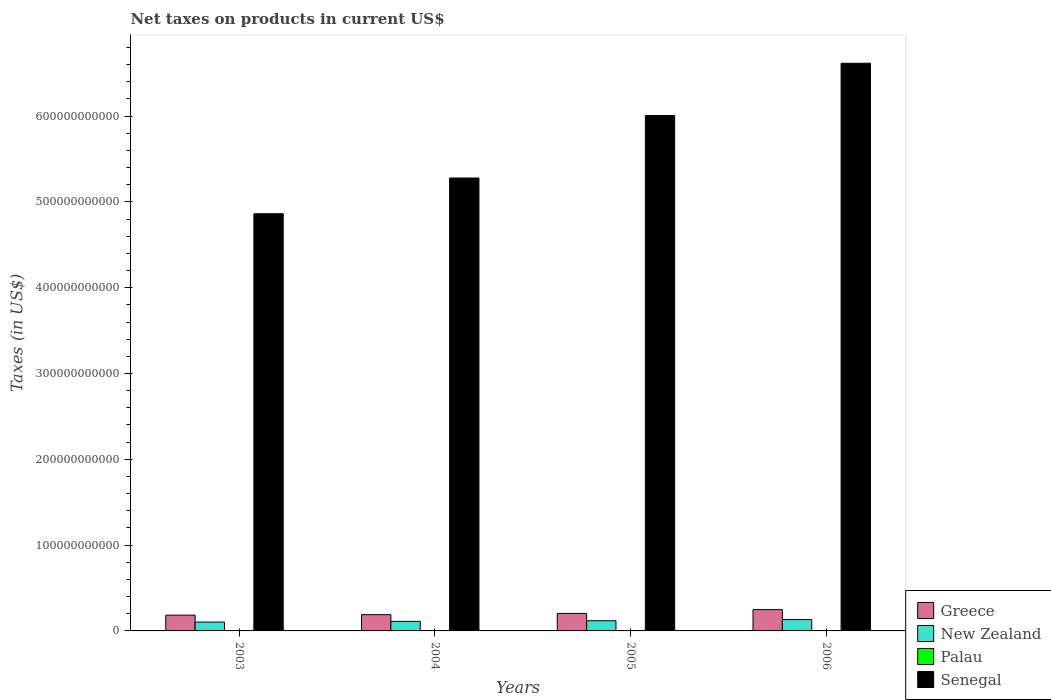How many different coloured bars are there?
Your answer should be compact. 4. What is the label of the 3rd group of bars from the left?
Offer a terse response. 2005. In how many cases, is the number of bars for a given year not equal to the number of legend labels?
Keep it short and to the point. 0. What is the net taxes on products in Greece in 2005?
Make the answer very short. 2.04e+1. Across all years, what is the maximum net taxes on products in Greece?
Your response must be concise. 2.48e+1. Across all years, what is the minimum net taxes on products in Greece?
Offer a very short reply. 1.84e+1. In which year was the net taxes on products in Greece maximum?
Make the answer very short. 2006. What is the total net taxes on products in Palau in the graph?
Provide a succinct answer. 6.83e+07. What is the difference between the net taxes on products in Senegal in 2004 and that in 2005?
Provide a succinct answer. -7.28e+1. What is the difference between the net taxes on products in New Zealand in 2006 and the net taxes on products in Senegal in 2004?
Make the answer very short. -5.15e+11. What is the average net taxes on products in Greece per year?
Provide a succinct answer. 2.06e+1. In the year 2005, what is the difference between the net taxes on products in New Zealand and net taxes on products in Palau?
Offer a terse response. 1.18e+1. In how many years, is the net taxes on products in Senegal greater than 280000000000 US$?
Offer a very short reply. 4. What is the ratio of the net taxes on products in Senegal in 2005 to that in 2006?
Make the answer very short. 0.91. Is the net taxes on products in New Zealand in 2005 less than that in 2006?
Offer a terse response. Yes. Is the difference between the net taxes on products in New Zealand in 2005 and 2006 greater than the difference between the net taxes on products in Palau in 2005 and 2006?
Provide a short and direct response. No. What is the difference between the highest and the second highest net taxes on products in Senegal?
Provide a short and direct response. 6.09e+1. What is the difference between the highest and the lowest net taxes on products in Senegal?
Offer a very short reply. 1.75e+11. Is the sum of the net taxes on products in New Zealand in 2003 and 2006 greater than the maximum net taxes on products in Senegal across all years?
Offer a terse response. No. What does the 2nd bar from the left in 2006 represents?
Offer a terse response. New Zealand. What does the 1st bar from the right in 2003 represents?
Keep it short and to the point. Senegal. Is it the case that in every year, the sum of the net taxes on products in Greece and net taxes on products in Senegal is greater than the net taxes on products in Palau?
Your answer should be very brief. Yes. How many years are there in the graph?
Provide a succinct answer. 4. What is the difference between two consecutive major ticks on the Y-axis?
Give a very brief answer. 1.00e+11. Are the values on the major ticks of Y-axis written in scientific E-notation?
Keep it short and to the point. No. Does the graph contain grids?
Your response must be concise. No. Where does the legend appear in the graph?
Offer a terse response. Bottom right. How many legend labels are there?
Your answer should be very brief. 4. What is the title of the graph?
Offer a very short reply. Net taxes on products in current US$. Does "Brazil" appear as one of the legend labels in the graph?
Your response must be concise. No. What is the label or title of the Y-axis?
Offer a terse response. Taxes (in US$). What is the Taxes (in US$) of Greece in 2003?
Your answer should be very brief. 1.84e+1. What is the Taxes (in US$) of New Zealand in 2003?
Provide a short and direct response. 1.03e+1. What is the Taxes (in US$) in Palau in 2003?
Provide a succinct answer. 1.38e+07. What is the Taxes (in US$) in Senegal in 2003?
Give a very brief answer. 4.86e+11. What is the Taxes (in US$) in Greece in 2004?
Keep it short and to the point. 1.89e+1. What is the Taxes (in US$) in New Zealand in 2004?
Offer a very short reply. 1.11e+1. What is the Taxes (in US$) in Palau in 2004?
Offer a very short reply. 1.66e+07. What is the Taxes (in US$) of Senegal in 2004?
Offer a very short reply. 5.28e+11. What is the Taxes (in US$) of Greece in 2005?
Provide a succinct answer. 2.04e+1. What is the Taxes (in US$) of New Zealand in 2005?
Give a very brief answer. 1.18e+1. What is the Taxes (in US$) of Palau in 2005?
Your answer should be very brief. 1.94e+07. What is the Taxes (in US$) in Senegal in 2005?
Your answer should be compact. 6.01e+11. What is the Taxes (in US$) in Greece in 2006?
Provide a succinct answer. 2.48e+1. What is the Taxes (in US$) of New Zealand in 2006?
Make the answer very short. 1.33e+1. What is the Taxes (in US$) of Palau in 2006?
Provide a short and direct response. 1.84e+07. What is the Taxes (in US$) of Senegal in 2006?
Provide a short and direct response. 6.62e+11. Across all years, what is the maximum Taxes (in US$) of Greece?
Provide a short and direct response. 2.48e+1. Across all years, what is the maximum Taxes (in US$) in New Zealand?
Offer a very short reply. 1.33e+1. Across all years, what is the maximum Taxes (in US$) in Palau?
Ensure brevity in your answer.  1.94e+07. Across all years, what is the maximum Taxes (in US$) of Senegal?
Your answer should be very brief. 6.62e+11. Across all years, what is the minimum Taxes (in US$) of Greece?
Give a very brief answer. 1.84e+1. Across all years, what is the minimum Taxes (in US$) in New Zealand?
Offer a very short reply. 1.03e+1. Across all years, what is the minimum Taxes (in US$) of Palau?
Provide a short and direct response. 1.38e+07. Across all years, what is the minimum Taxes (in US$) of Senegal?
Give a very brief answer. 4.86e+11. What is the total Taxes (in US$) in Greece in the graph?
Offer a very short reply. 8.26e+1. What is the total Taxes (in US$) in New Zealand in the graph?
Ensure brevity in your answer.  4.65e+1. What is the total Taxes (in US$) in Palau in the graph?
Your answer should be compact. 6.83e+07. What is the total Taxes (in US$) in Senegal in the graph?
Your answer should be compact. 2.28e+12. What is the difference between the Taxes (in US$) of Greece in 2003 and that in 2004?
Your answer should be compact. -5.51e+08. What is the difference between the Taxes (in US$) in New Zealand in 2003 and that in 2004?
Your answer should be very brief. -8.52e+08. What is the difference between the Taxes (in US$) in Palau in 2003 and that in 2004?
Your response must be concise. -2.81e+06. What is the difference between the Taxes (in US$) in Senegal in 2003 and that in 2004?
Give a very brief answer. -4.17e+1. What is the difference between the Taxes (in US$) of Greece in 2003 and that in 2005?
Your answer should be compact. -2.03e+09. What is the difference between the Taxes (in US$) in New Zealand in 2003 and that in 2005?
Offer a very short reply. -1.55e+09. What is the difference between the Taxes (in US$) of Palau in 2003 and that in 2005?
Offer a very short reply. -5.60e+06. What is the difference between the Taxes (in US$) in Senegal in 2003 and that in 2005?
Give a very brief answer. -1.14e+11. What is the difference between the Taxes (in US$) in Greece in 2003 and that in 2006?
Keep it short and to the point. -6.42e+09. What is the difference between the Taxes (in US$) in New Zealand in 2003 and that in 2006?
Your response must be concise. -2.96e+09. What is the difference between the Taxes (in US$) in Palau in 2003 and that in 2006?
Your answer should be compact. -4.54e+06. What is the difference between the Taxes (in US$) in Senegal in 2003 and that in 2006?
Keep it short and to the point. -1.75e+11. What is the difference between the Taxes (in US$) in Greece in 2004 and that in 2005?
Your response must be concise. -1.48e+09. What is the difference between the Taxes (in US$) of New Zealand in 2004 and that in 2005?
Offer a terse response. -6.97e+08. What is the difference between the Taxes (in US$) of Palau in 2004 and that in 2005?
Ensure brevity in your answer.  -2.78e+06. What is the difference between the Taxes (in US$) in Senegal in 2004 and that in 2005?
Your answer should be compact. -7.28e+1. What is the difference between the Taxes (in US$) in Greece in 2004 and that in 2006?
Make the answer very short. -5.87e+09. What is the difference between the Taxes (in US$) of New Zealand in 2004 and that in 2006?
Make the answer very short. -2.11e+09. What is the difference between the Taxes (in US$) in Palau in 2004 and that in 2006?
Ensure brevity in your answer.  -1.73e+06. What is the difference between the Taxes (in US$) of Senegal in 2004 and that in 2006?
Your answer should be compact. -1.34e+11. What is the difference between the Taxes (in US$) of Greece in 2005 and that in 2006?
Your answer should be very brief. -4.39e+09. What is the difference between the Taxes (in US$) in New Zealand in 2005 and that in 2006?
Make the answer very short. -1.41e+09. What is the difference between the Taxes (in US$) in Palau in 2005 and that in 2006?
Offer a terse response. 1.05e+06. What is the difference between the Taxes (in US$) of Senegal in 2005 and that in 2006?
Make the answer very short. -6.09e+1. What is the difference between the Taxes (in US$) of Greece in 2003 and the Taxes (in US$) of New Zealand in 2004?
Provide a succinct answer. 7.25e+09. What is the difference between the Taxes (in US$) in Greece in 2003 and the Taxes (in US$) in Palau in 2004?
Your answer should be compact. 1.84e+1. What is the difference between the Taxes (in US$) of Greece in 2003 and the Taxes (in US$) of Senegal in 2004?
Offer a very short reply. -5.09e+11. What is the difference between the Taxes (in US$) in New Zealand in 2003 and the Taxes (in US$) in Palau in 2004?
Make the answer very short. 1.03e+1. What is the difference between the Taxes (in US$) of New Zealand in 2003 and the Taxes (in US$) of Senegal in 2004?
Keep it short and to the point. -5.18e+11. What is the difference between the Taxes (in US$) of Palau in 2003 and the Taxes (in US$) of Senegal in 2004?
Keep it short and to the point. -5.28e+11. What is the difference between the Taxes (in US$) in Greece in 2003 and the Taxes (in US$) in New Zealand in 2005?
Make the answer very short. 6.55e+09. What is the difference between the Taxes (in US$) of Greece in 2003 and the Taxes (in US$) of Palau in 2005?
Ensure brevity in your answer.  1.84e+1. What is the difference between the Taxes (in US$) in Greece in 2003 and the Taxes (in US$) in Senegal in 2005?
Offer a very short reply. -5.82e+11. What is the difference between the Taxes (in US$) in New Zealand in 2003 and the Taxes (in US$) in Palau in 2005?
Give a very brief answer. 1.03e+1. What is the difference between the Taxes (in US$) in New Zealand in 2003 and the Taxes (in US$) in Senegal in 2005?
Give a very brief answer. -5.90e+11. What is the difference between the Taxes (in US$) in Palau in 2003 and the Taxes (in US$) in Senegal in 2005?
Your answer should be very brief. -6.01e+11. What is the difference between the Taxes (in US$) in Greece in 2003 and the Taxes (in US$) in New Zealand in 2006?
Offer a very short reply. 5.14e+09. What is the difference between the Taxes (in US$) in Greece in 2003 and the Taxes (in US$) in Palau in 2006?
Provide a short and direct response. 1.84e+1. What is the difference between the Taxes (in US$) in Greece in 2003 and the Taxes (in US$) in Senegal in 2006?
Provide a succinct answer. -6.43e+11. What is the difference between the Taxes (in US$) of New Zealand in 2003 and the Taxes (in US$) of Palau in 2006?
Ensure brevity in your answer.  1.03e+1. What is the difference between the Taxes (in US$) in New Zealand in 2003 and the Taxes (in US$) in Senegal in 2006?
Ensure brevity in your answer.  -6.51e+11. What is the difference between the Taxes (in US$) of Palau in 2003 and the Taxes (in US$) of Senegal in 2006?
Keep it short and to the point. -6.62e+11. What is the difference between the Taxes (in US$) of Greece in 2004 and the Taxes (in US$) of New Zealand in 2005?
Offer a very short reply. 7.10e+09. What is the difference between the Taxes (in US$) in Greece in 2004 and the Taxes (in US$) in Palau in 2005?
Offer a very short reply. 1.89e+1. What is the difference between the Taxes (in US$) of Greece in 2004 and the Taxes (in US$) of Senegal in 2005?
Provide a short and direct response. -5.82e+11. What is the difference between the Taxes (in US$) of New Zealand in 2004 and the Taxes (in US$) of Palau in 2005?
Your answer should be compact. 1.11e+1. What is the difference between the Taxes (in US$) of New Zealand in 2004 and the Taxes (in US$) of Senegal in 2005?
Your answer should be compact. -5.90e+11. What is the difference between the Taxes (in US$) in Palau in 2004 and the Taxes (in US$) in Senegal in 2005?
Keep it short and to the point. -6.01e+11. What is the difference between the Taxes (in US$) in Greece in 2004 and the Taxes (in US$) in New Zealand in 2006?
Give a very brief answer. 5.69e+09. What is the difference between the Taxes (in US$) of Greece in 2004 and the Taxes (in US$) of Palau in 2006?
Your response must be concise. 1.89e+1. What is the difference between the Taxes (in US$) of Greece in 2004 and the Taxes (in US$) of Senegal in 2006?
Provide a short and direct response. -6.43e+11. What is the difference between the Taxes (in US$) in New Zealand in 2004 and the Taxes (in US$) in Palau in 2006?
Give a very brief answer. 1.11e+1. What is the difference between the Taxes (in US$) in New Zealand in 2004 and the Taxes (in US$) in Senegal in 2006?
Your answer should be very brief. -6.50e+11. What is the difference between the Taxes (in US$) in Palau in 2004 and the Taxes (in US$) in Senegal in 2006?
Your answer should be very brief. -6.62e+11. What is the difference between the Taxes (in US$) in Greece in 2005 and the Taxes (in US$) in New Zealand in 2006?
Provide a succinct answer. 7.17e+09. What is the difference between the Taxes (in US$) of Greece in 2005 and the Taxes (in US$) of Palau in 2006?
Offer a terse response. 2.04e+1. What is the difference between the Taxes (in US$) in Greece in 2005 and the Taxes (in US$) in Senegal in 2006?
Your answer should be compact. -6.41e+11. What is the difference between the Taxes (in US$) of New Zealand in 2005 and the Taxes (in US$) of Palau in 2006?
Keep it short and to the point. 1.18e+1. What is the difference between the Taxes (in US$) of New Zealand in 2005 and the Taxes (in US$) of Senegal in 2006?
Make the answer very short. -6.50e+11. What is the difference between the Taxes (in US$) of Palau in 2005 and the Taxes (in US$) of Senegal in 2006?
Offer a very short reply. -6.62e+11. What is the average Taxes (in US$) in Greece per year?
Your answer should be compact. 2.06e+1. What is the average Taxes (in US$) in New Zealand per year?
Make the answer very short. 1.16e+1. What is the average Taxes (in US$) of Palau per year?
Provide a short and direct response. 1.71e+07. What is the average Taxes (in US$) in Senegal per year?
Provide a succinct answer. 5.69e+11. In the year 2003, what is the difference between the Taxes (in US$) in Greece and Taxes (in US$) in New Zealand?
Provide a succinct answer. 8.10e+09. In the year 2003, what is the difference between the Taxes (in US$) in Greece and Taxes (in US$) in Palau?
Your answer should be very brief. 1.84e+1. In the year 2003, what is the difference between the Taxes (in US$) in Greece and Taxes (in US$) in Senegal?
Your answer should be very brief. -4.68e+11. In the year 2003, what is the difference between the Taxes (in US$) of New Zealand and Taxes (in US$) of Palau?
Provide a short and direct response. 1.03e+1. In the year 2003, what is the difference between the Taxes (in US$) in New Zealand and Taxes (in US$) in Senegal?
Make the answer very short. -4.76e+11. In the year 2003, what is the difference between the Taxes (in US$) in Palau and Taxes (in US$) in Senegal?
Make the answer very short. -4.86e+11. In the year 2004, what is the difference between the Taxes (in US$) of Greece and Taxes (in US$) of New Zealand?
Your answer should be very brief. 7.80e+09. In the year 2004, what is the difference between the Taxes (in US$) of Greece and Taxes (in US$) of Palau?
Offer a very short reply. 1.89e+1. In the year 2004, what is the difference between the Taxes (in US$) of Greece and Taxes (in US$) of Senegal?
Your answer should be compact. -5.09e+11. In the year 2004, what is the difference between the Taxes (in US$) in New Zealand and Taxes (in US$) in Palau?
Give a very brief answer. 1.11e+1. In the year 2004, what is the difference between the Taxes (in US$) of New Zealand and Taxes (in US$) of Senegal?
Give a very brief answer. -5.17e+11. In the year 2004, what is the difference between the Taxes (in US$) in Palau and Taxes (in US$) in Senegal?
Offer a terse response. -5.28e+11. In the year 2005, what is the difference between the Taxes (in US$) of Greece and Taxes (in US$) of New Zealand?
Your response must be concise. 8.58e+09. In the year 2005, what is the difference between the Taxes (in US$) in Greece and Taxes (in US$) in Palau?
Your response must be concise. 2.04e+1. In the year 2005, what is the difference between the Taxes (in US$) of Greece and Taxes (in US$) of Senegal?
Your answer should be very brief. -5.80e+11. In the year 2005, what is the difference between the Taxes (in US$) in New Zealand and Taxes (in US$) in Palau?
Keep it short and to the point. 1.18e+1. In the year 2005, what is the difference between the Taxes (in US$) in New Zealand and Taxes (in US$) in Senegal?
Keep it short and to the point. -5.89e+11. In the year 2005, what is the difference between the Taxes (in US$) in Palau and Taxes (in US$) in Senegal?
Make the answer very short. -6.01e+11. In the year 2006, what is the difference between the Taxes (in US$) of Greece and Taxes (in US$) of New Zealand?
Your answer should be very brief. 1.16e+1. In the year 2006, what is the difference between the Taxes (in US$) in Greece and Taxes (in US$) in Palau?
Offer a very short reply. 2.48e+1. In the year 2006, what is the difference between the Taxes (in US$) in Greece and Taxes (in US$) in Senegal?
Give a very brief answer. -6.37e+11. In the year 2006, what is the difference between the Taxes (in US$) of New Zealand and Taxes (in US$) of Palau?
Make the answer very short. 1.32e+1. In the year 2006, what is the difference between the Taxes (in US$) of New Zealand and Taxes (in US$) of Senegal?
Your answer should be compact. -6.48e+11. In the year 2006, what is the difference between the Taxes (in US$) of Palau and Taxes (in US$) of Senegal?
Ensure brevity in your answer.  -6.62e+11. What is the ratio of the Taxes (in US$) of Greece in 2003 to that in 2004?
Make the answer very short. 0.97. What is the ratio of the Taxes (in US$) of New Zealand in 2003 to that in 2004?
Provide a short and direct response. 0.92. What is the ratio of the Taxes (in US$) in Palau in 2003 to that in 2004?
Keep it short and to the point. 0.83. What is the ratio of the Taxes (in US$) of Senegal in 2003 to that in 2004?
Your answer should be very brief. 0.92. What is the ratio of the Taxes (in US$) of Greece in 2003 to that in 2005?
Your answer should be compact. 0.9. What is the ratio of the Taxes (in US$) of New Zealand in 2003 to that in 2005?
Make the answer very short. 0.87. What is the ratio of the Taxes (in US$) in Palau in 2003 to that in 2005?
Provide a short and direct response. 0.71. What is the ratio of the Taxes (in US$) in Senegal in 2003 to that in 2005?
Your answer should be compact. 0.81. What is the ratio of the Taxes (in US$) of Greece in 2003 to that in 2006?
Offer a very short reply. 0.74. What is the ratio of the Taxes (in US$) in New Zealand in 2003 to that in 2006?
Offer a very short reply. 0.78. What is the ratio of the Taxes (in US$) in Palau in 2003 to that in 2006?
Provide a succinct answer. 0.75. What is the ratio of the Taxes (in US$) in Senegal in 2003 to that in 2006?
Offer a very short reply. 0.73. What is the ratio of the Taxes (in US$) of Greece in 2004 to that in 2005?
Offer a terse response. 0.93. What is the ratio of the Taxes (in US$) of Palau in 2004 to that in 2005?
Your answer should be very brief. 0.86. What is the ratio of the Taxes (in US$) of Senegal in 2004 to that in 2005?
Ensure brevity in your answer.  0.88. What is the ratio of the Taxes (in US$) of Greece in 2004 to that in 2006?
Ensure brevity in your answer.  0.76. What is the ratio of the Taxes (in US$) in New Zealand in 2004 to that in 2006?
Ensure brevity in your answer.  0.84. What is the ratio of the Taxes (in US$) of Palau in 2004 to that in 2006?
Provide a short and direct response. 0.91. What is the ratio of the Taxes (in US$) of Senegal in 2004 to that in 2006?
Your answer should be compact. 0.8. What is the ratio of the Taxes (in US$) of Greece in 2005 to that in 2006?
Your response must be concise. 0.82. What is the ratio of the Taxes (in US$) in New Zealand in 2005 to that in 2006?
Ensure brevity in your answer.  0.89. What is the ratio of the Taxes (in US$) of Palau in 2005 to that in 2006?
Your answer should be very brief. 1.06. What is the ratio of the Taxes (in US$) in Senegal in 2005 to that in 2006?
Ensure brevity in your answer.  0.91. What is the difference between the highest and the second highest Taxes (in US$) of Greece?
Your answer should be compact. 4.39e+09. What is the difference between the highest and the second highest Taxes (in US$) of New Zealand?
Your answer should be very brief. 1.41e+09. What is the difference between the highest and the second highest Taxes (in US$) of Palau?
Your answer should be very brief. 1.05e+06. What is the difference between the highest and the second highest Taxes (in US$) of Senegal?
Provide a succinct answer. 6.09e+1. What is the difference between the highest and the lowest Taxes (in US$) of Greece?
Give a very brief answer. 6.42e+09. What is the difference between the highest and the lowest Taxes (in US$) in New Zealand?
Your answer should be very brief. 2.96e+09. What is the difference between the highest and the lowest Taxes (in US$) of Palau?
Ensure brevity in your answer.  5.60e+06. What is the difference between the highest and the lowest Taxes (in US$) in Senegal?
Your answer should be very brief. 1.75e+11. 